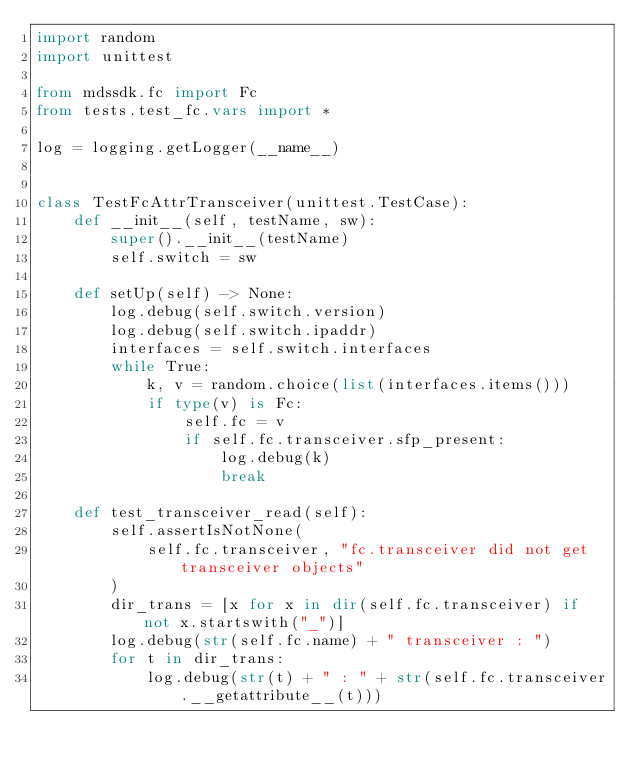Convert code to text. <code><loc_0><loc_0><loc_500><loc_500><_Python_>import random
import unittest

from mdssdk.fc import Fc
from tests.test_fc.vars import *

log = logging.getLogger(__name__)


class TestFcAttrTransceiver(unittest.TestCase):
    def __init__(self, testName, sw):
        super().__init__(testName)
        self.switch = sw

    def setUp(self) -> None:
        log.debug(self.switch.version)
        log.debug(self.switch.ipaddr)
        interfaces = self.switch.interfaces
        while True:
            k, v = random.choice(list(interfaces.items()))
            if type(v) is Fc:
                self.fc = v
                if self.fc.transceiver.sfp_present:
                    log.debug(k)
                    break

    def test_transceiver_read(self):
        self.assertIsNotNone(
            self.fc.transceiver, "fc.transceiver did not get transceiver objects"
        )
        dir_trans = [x for x in dir(self.fc.transceiver) if not x.startswith("_")]
        log.debug(str(self.fc.name) + " transceiver : ")
        for t in dir_trans:
            log.debug(str(t) + " : " + str(self.fc.transceiver.__getattribute__(t)))</code> 